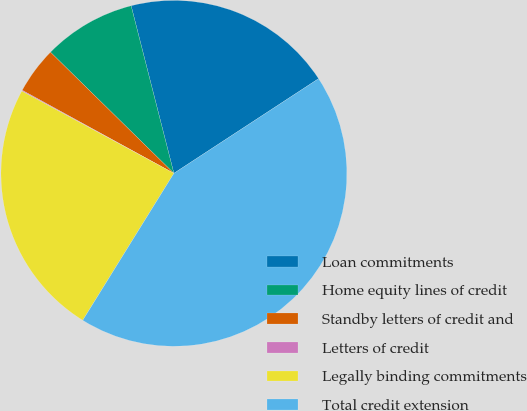Convert chart to OTSL. <chart><loc_0><loc_0><loc_500><loc_500><pie_chart><fcel>Loan commitments<fcel>Home equity lines of credit<fcel>Standby letters of credit and<fcel>Letters of credit<fcel>Legally binding commitments<fcel>Total credit extension<nl><fcel>19.76%<fcel>8.67%<fcel>4.38%<fcel>0.08%<fcel>24.06%<fcel>43.06%<nl></chart> 